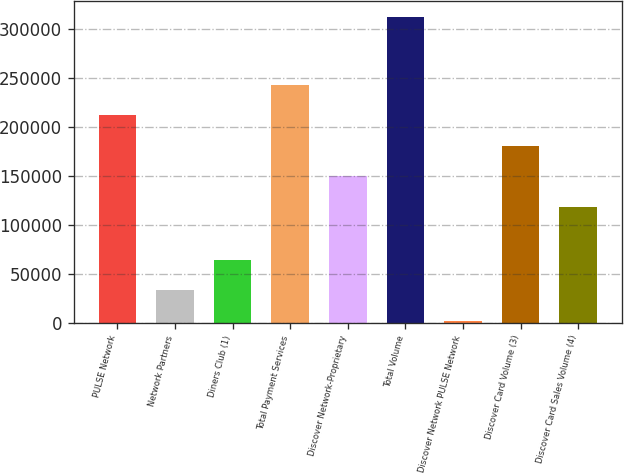Convert chart. <chart><loc_0><loc_0><loc_500><loc_500><bar_chart><fcel>PULSE Network<fcel>Network Partners<fcel>Diners Club (1)<fcel>Total Payment Services<fcel>Discover Network-Proprietary<fcel>Total Volume<fcel>Discover Network PULSE Network<fcel>Discover Card Volume (3)<fcel>Discover Card Sales Volume (4)<nl><fcel>211553<fcel>33070<fcel>64107<fcel>242590<fcel>149479<fcel>312403<fcel>2033<fcel>180516<fcel>118442<nl></chart> 